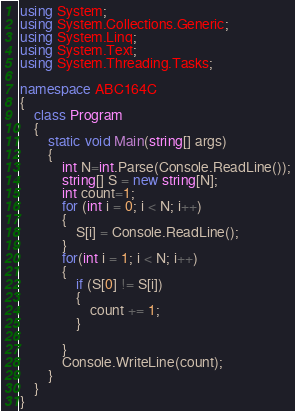Convert code to text. <code><loc_0><loc_0><loc_500><loc_500><_C#_>using System;
using System.Collections.Generic;
using System.Linq;
using System.Text;
using System.Threading.Tasks;

namespace ABC164C
{
    class Program
    {
        static void Main(string[] args)
        {
            int N=int.Parse(Console.ReadLine());
            string[] S = new string[N];
            int count=1;
            for (int i = 0; i < N; i++)
            {
                S[i] = Console.ReadLine();
            }
            for(int i = 1; i < N; i++)
            {
                if (S[0] != S[i])
                {
                    count += 1;
                }
                
            }
            Console.WriteLine(count);
        }
    }
}
</code> 